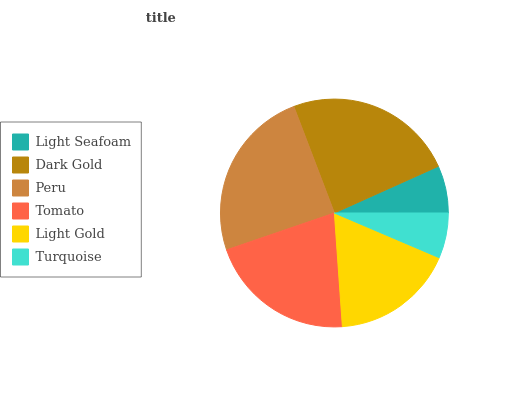Is Turquoise the minimum?
Answer yes or no. Yes. Is Peru the maximum?
Answer yes or no. Yes. Is Dark Gold the minimum?
Answer yes or no. No. Is Dark Gold the maximum?
Answer yes or no. No. Is Dark Gold greater than Light Seafoam?
Answer yes or no. Yes. Is Light Seafoam less than Dark Gold?
Answer yes or no. Yes. Is Light Seafoam greater than Dark Gold?
Answer yes or no. No. Is Dark Gold less than Light Seafoam?
Answer yes or no. No. Is Tomato the high median?
Answer yes or no. Yes. Is Light Gold the low median?
Answer yes or no. Yes. Is Peru the high median?
Answer yes or no. No. Is Tomato the low median?
Answer yes or no. No. 